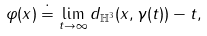<formula> <loc_0><loc_0><loc_500><loc_500>\varphi ( x ) \doteq \lim _ { t \rightarrow \infty } d _ { \mathbb { H } ^ { 3 } } ( x , \gamma ( t ) ) - t ,</formula> 